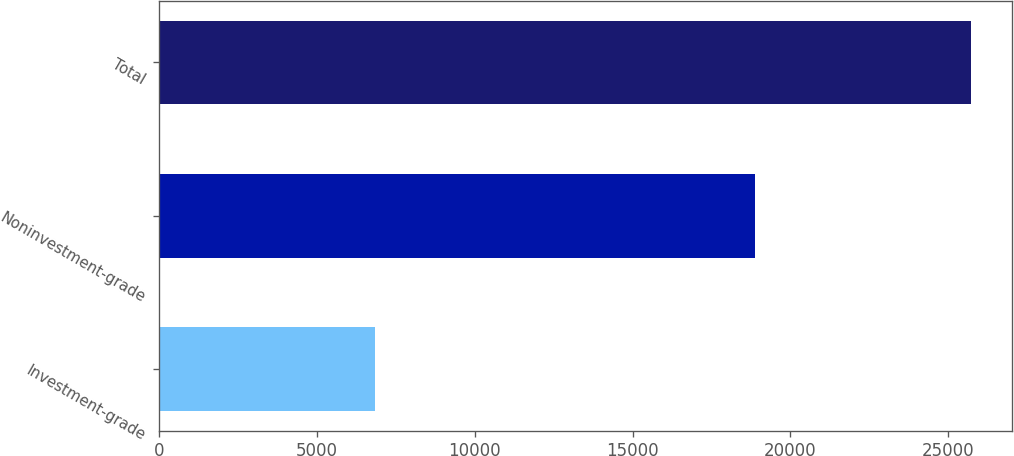Convert chart. <chart><loc_0><loc_0><loc_500><loc_500><bar_chart><fcel>Investment-grade<fcel>Noninvestment-grade<fcel>Total<nl><fcel>6836<fcel>18891<fcel>25727<nl></chart> 